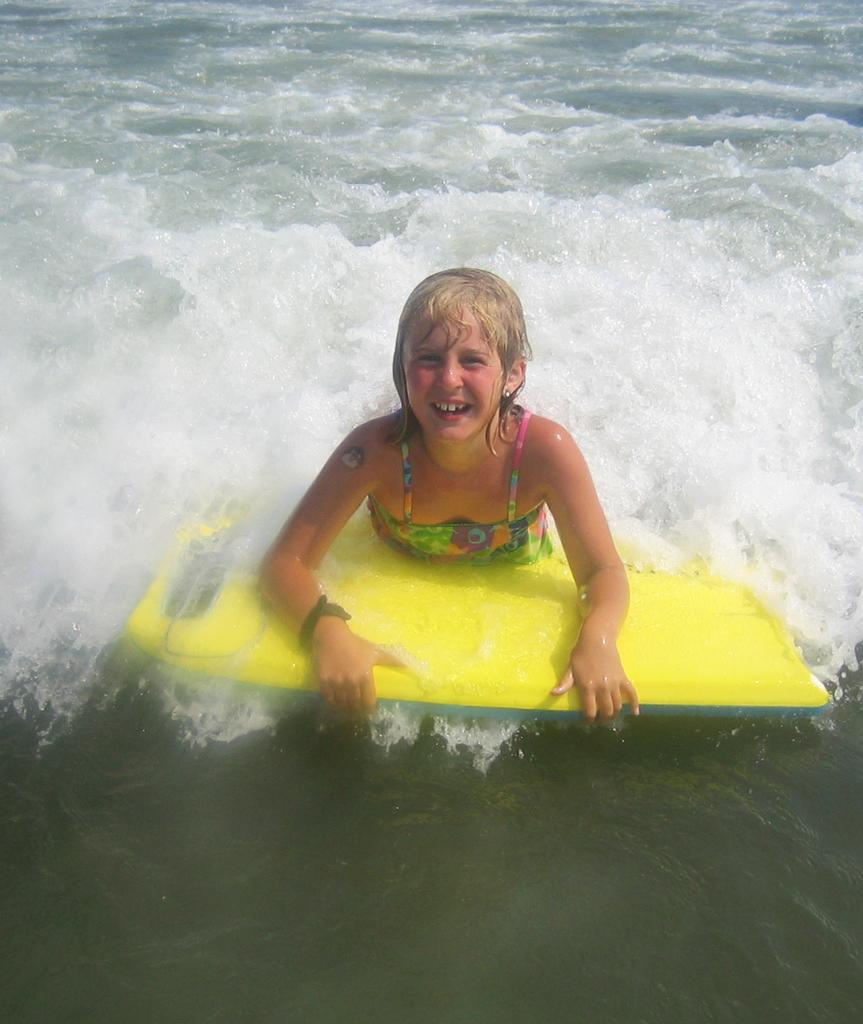Where was the image taken? The image was taken outdoors. Who is present in the image? There is a woman in the image. What is the woman holding in the image? The woman is holding a board. What is the woman's position in relation to the water? The woman is floating on water. What type of agreement is the woman discussing with the plastic in the image? There is no plastic present in the image, and the woman is not discussing any agreements. 